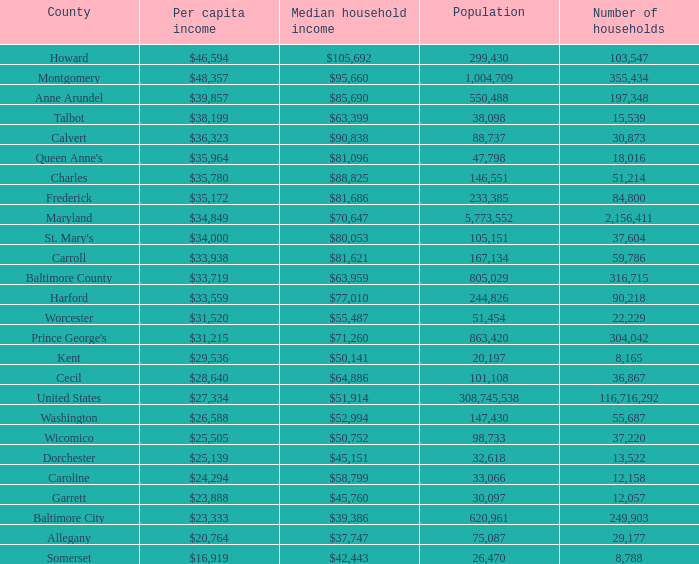What is the average income per person in washington county? $26,588. 